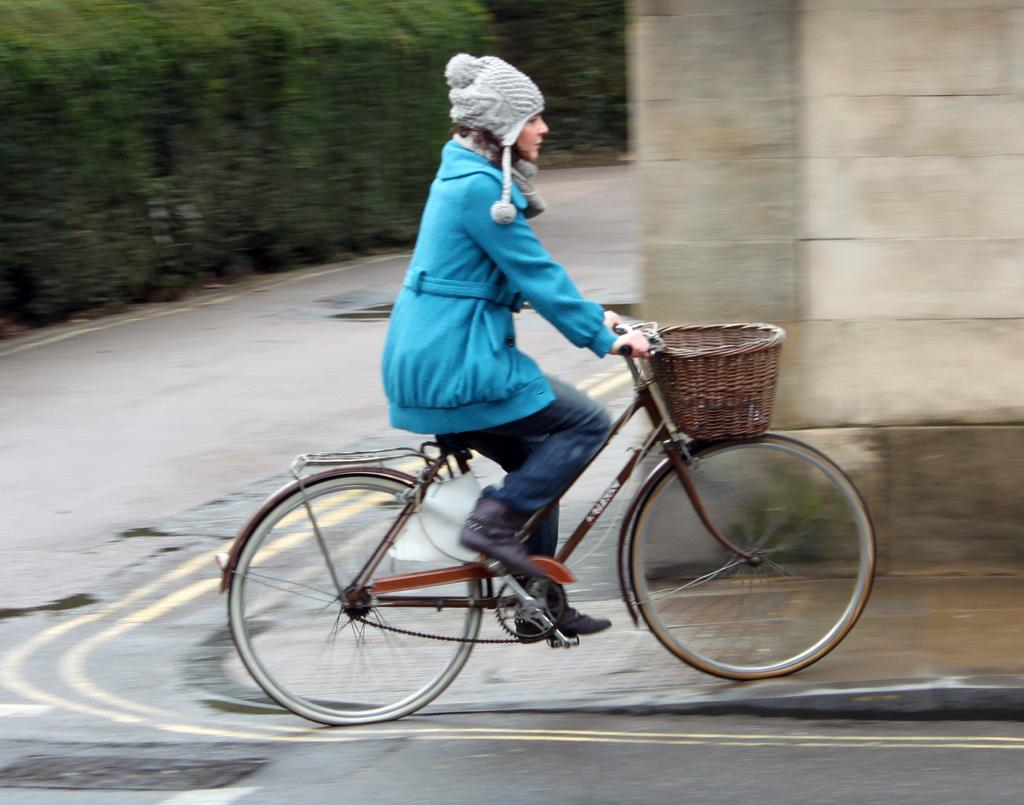Who is the main subject in the image? There is a girl in the image. What is the girl wearing? The girl is wearing a sweatshirt. What activity is the girl engaged in? The girl is riding a bicycle. Where is the bicycle located? The bicycle is on the road. What can be seen in the background of the image? There are plants in the background of the image. Where is the girl's mom in the image? There is no mention of the girl's mom in the image, so we cannot determine her location. 